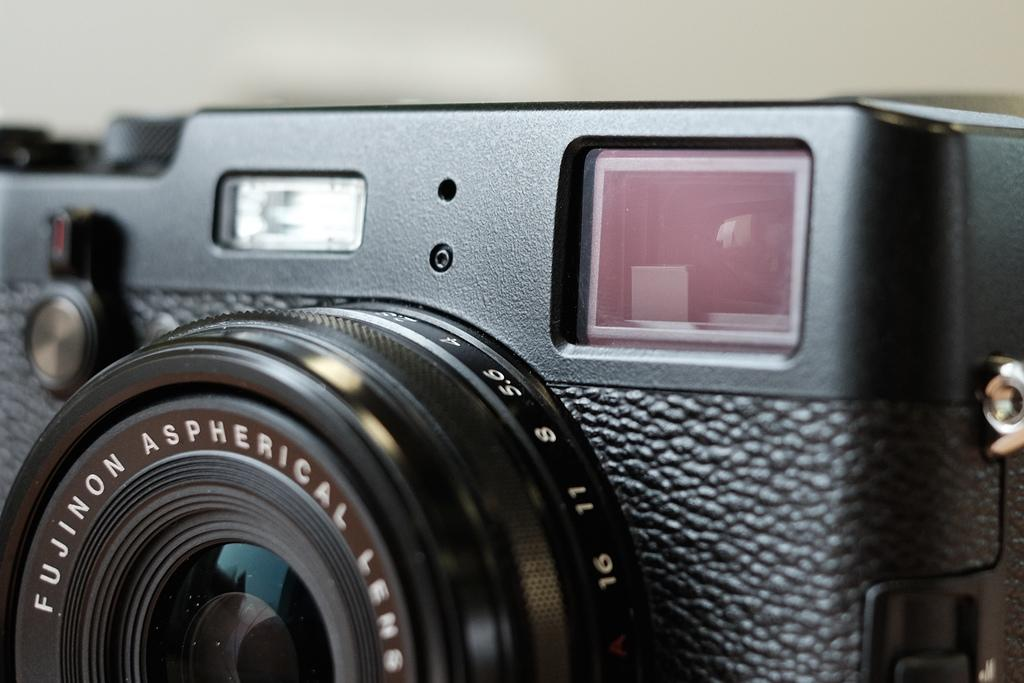What is the main object in the image? There is a camera in the image. What color is the background of the image? The background of the image is white. What type of brush is used to clean the camera in the image? There is no brush present in the image, and no cleaning activity is depicted. 